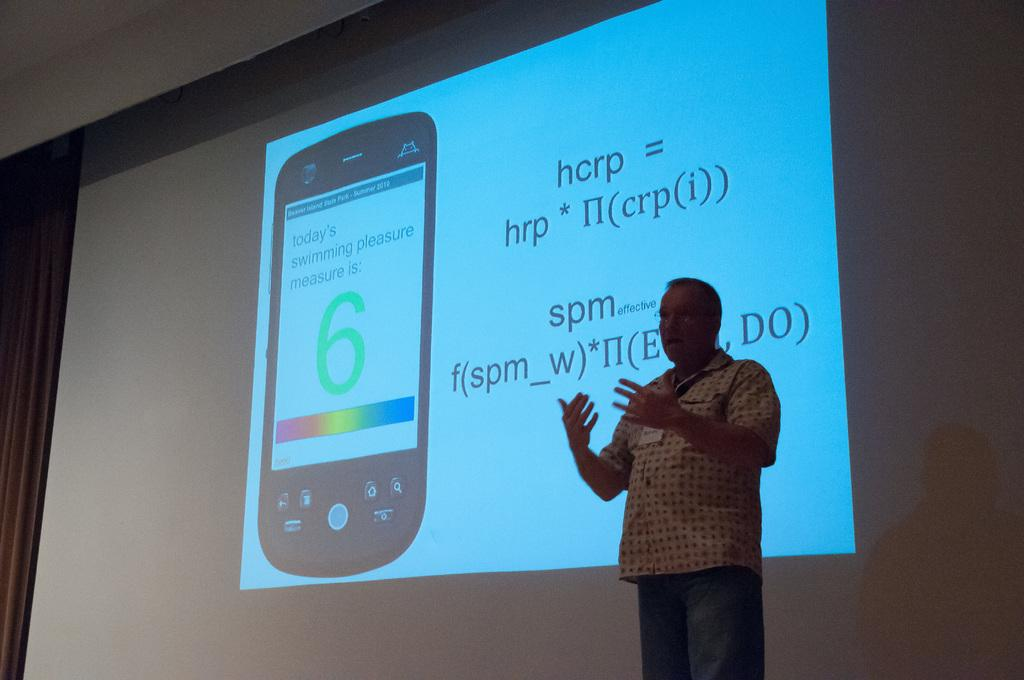<image>
Provide a brief description of the given image. A man lecturing in front of a screen that has an equation for hcrp and spm 